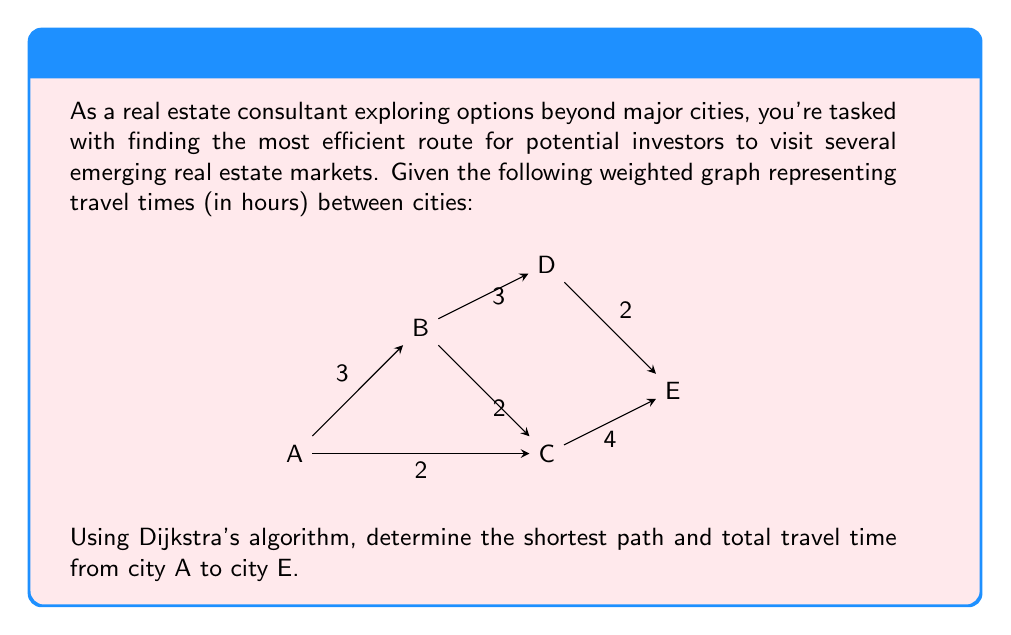What is the answer to this math problem? To solve this problem using Dijkstra's algorithm, we'll follow these steps:

1) Initialize:
   - Set distance to A as 0, and all other cities as infinity.
   - Set all cities as unvisited.
   - Set A as the current city.

2) For the current city, consider all unvisited neighbors and calculate their tentative distances.
3) Mark the current city as visited.
4) If the destination city (E) has been marked visited, we're done. Otherwise, select the unvisited city with the smallest tentative distance and set it as the new current city. Go back to step 2.

Let's apply the algorithm:

Step 1: Initialize
$$ \begin{array}{l|ccccc}
\text{City} & A & B & C & D & E \\
\hline
\text{Distance} & 0 & \infty & \infty & \infty & \infty \\
\text{Previous} & - & - & - & - & - \\
\end{array} $$

Step 2-4: Process A
- Update B: 0 + 3 = 3
- Update C: 0 + 2 = 2
$$ \begin{array}{l|ccccc}
\text{City} & A & B & C & D & E \\
\hline
\text{Distance} & 0 & 3 & 2 & \infty & \infty \\
\text{Previous} & - & A & A & - & - \\
\end{array} $$

Step 2-4: Process C (smallest unvisited)
- Update B: 2 + 2 = 4 > 3, no change
- Update E: 2 + 4 = 6
$$ \begin{array}{l|ccccc}
\text{City} & A & B & C & D & E \\
\hline
\text{Distance} & 0 & 3 & 2 & \infty & 6 \\
\text{Previous} & - & A & A & - & C \\
\end{array} $$

Step 2-4: Process B
- Update D: 3 + 3 = 6
$$ \begin{array}{l|ccccc}
\text{City} & A & B & C & D & E \\
\hline
\text{Distance} & 0 & 3 & 2 & 6 & 6 \\
\text{Previous} & - & A & A & B & C \\
\end{array} $$

Step 2-4: Process E (D and E have same distance, choose E as it's our destination)
Algorithm terminates as we've reached the destination.

The shortest path is determined by backtracking from E:
E ← C ← A

The total travel time is 6 hours.
Answer: The shortest path from A to E is A → C → E, with a total travel time of 6 hours. 